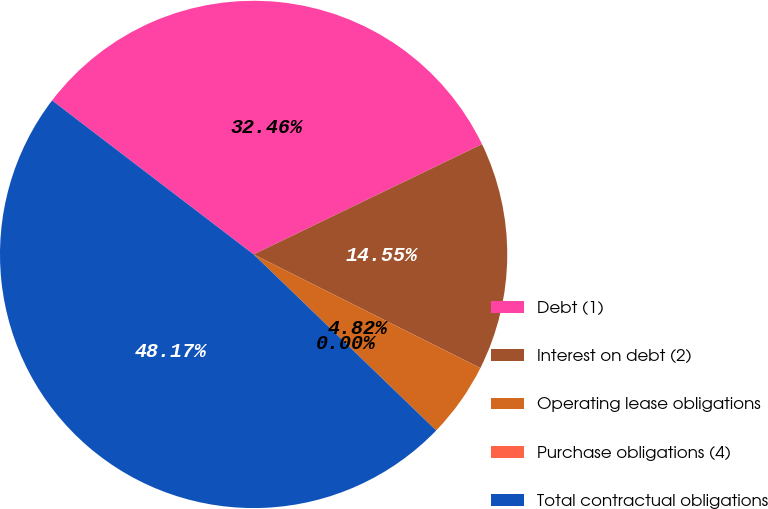Convert chart to OTSL. <chart><loc_0><loc_0><loc_500><loc_500><pie_chart><fcel>Debt (1)<fcel>Interest on debt (2)<fcel>Operating lease obligations<fcel>Purchase obligations (4)<fcel>Total contractual obligations<nl><fcel>32.46%<fcel>14.55%<fcel>4.82%<fcel>0.0%<fcel>48.17%<nl></chart> 